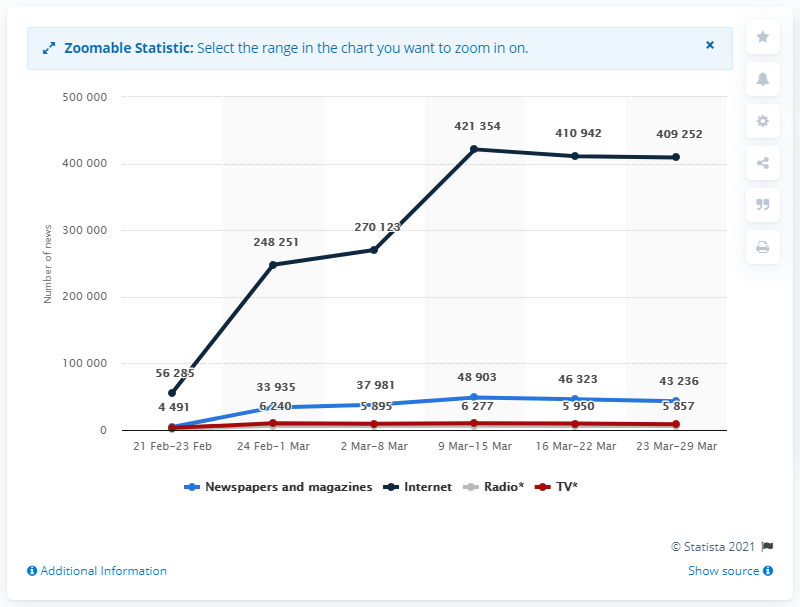How many news releases were there between March 9 and 15? According to the depicted line graph, there were a total of 48,903 news releases from the Internet sources between March 9 and March 15, 2021. 